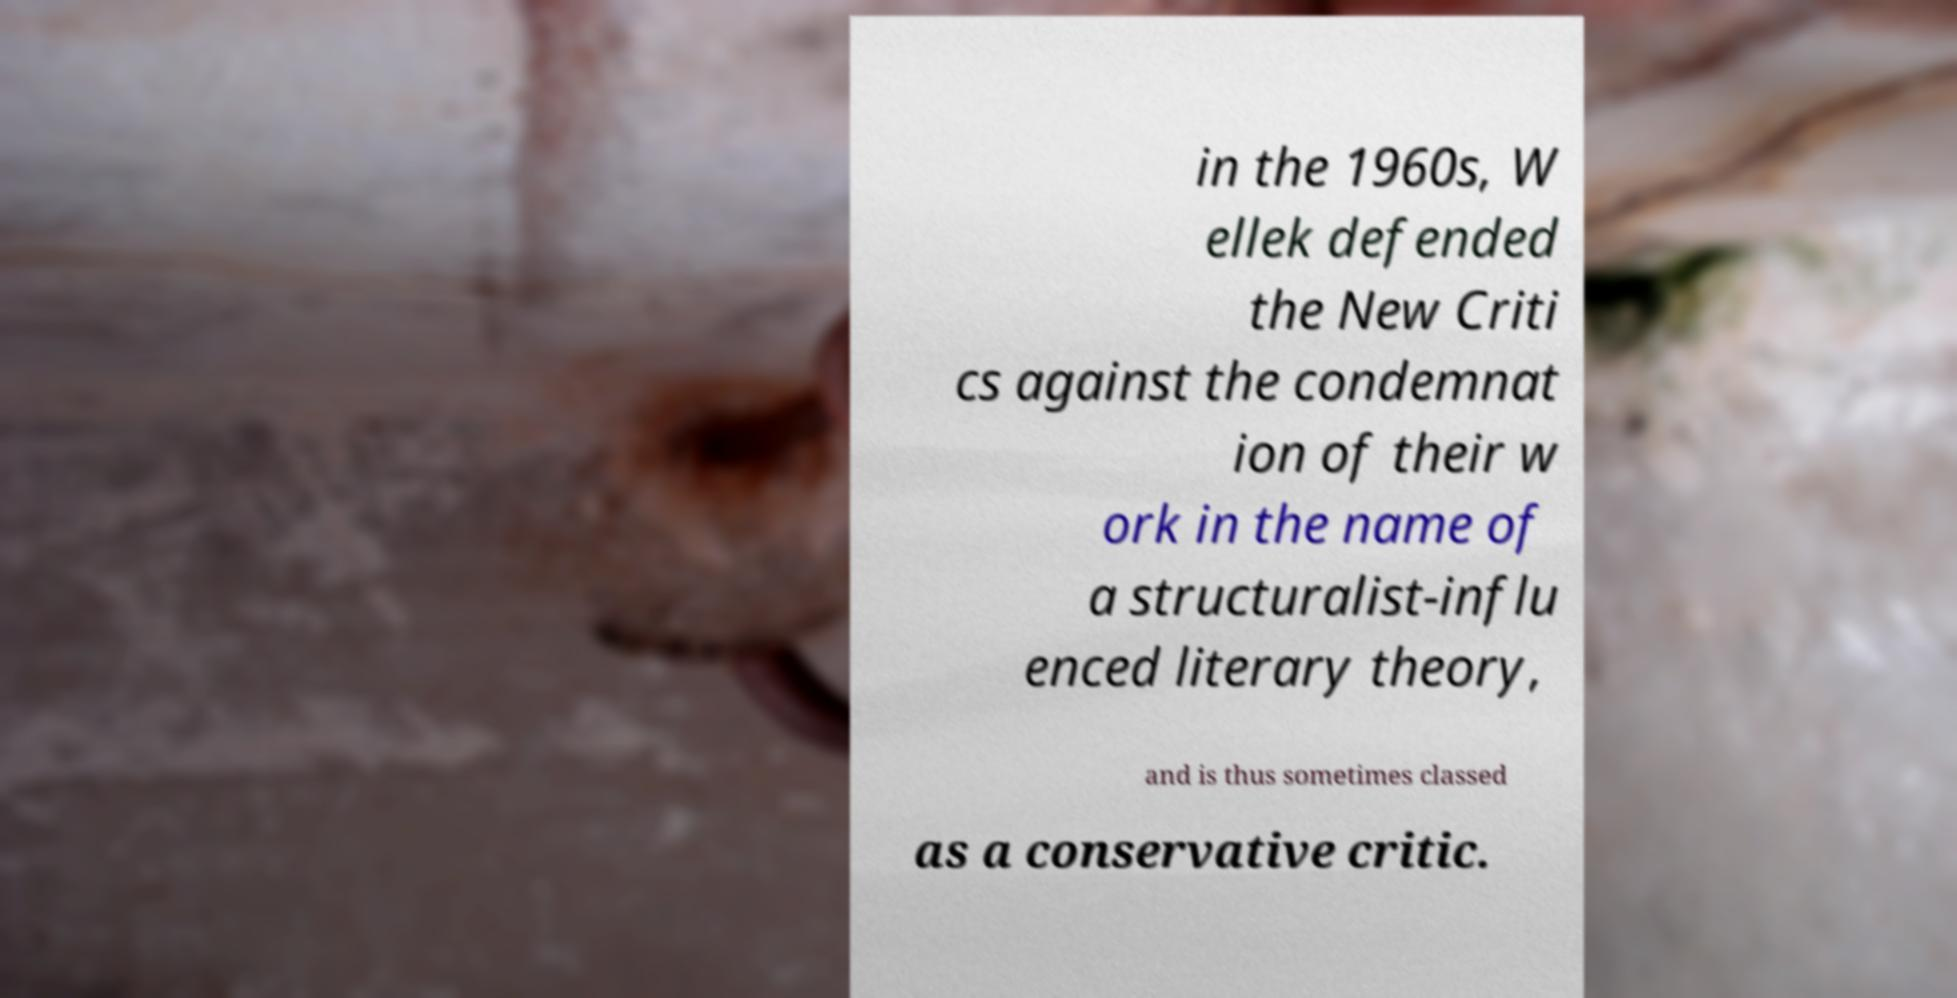What messages or text are displayed in this image? I need them in a readable, typed format. in the 1960s, W ellek defended the New Criti cs against the condemnat ion of their w ork in the name of a structuralist-influ enced literary theory, and is thus sometimes classed as a conservative critic. 